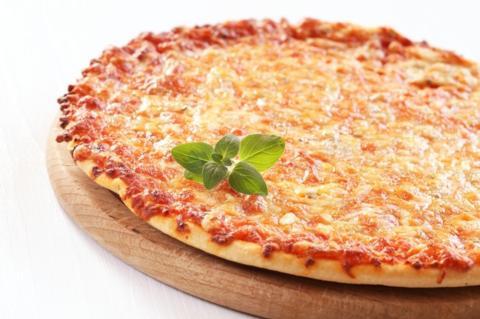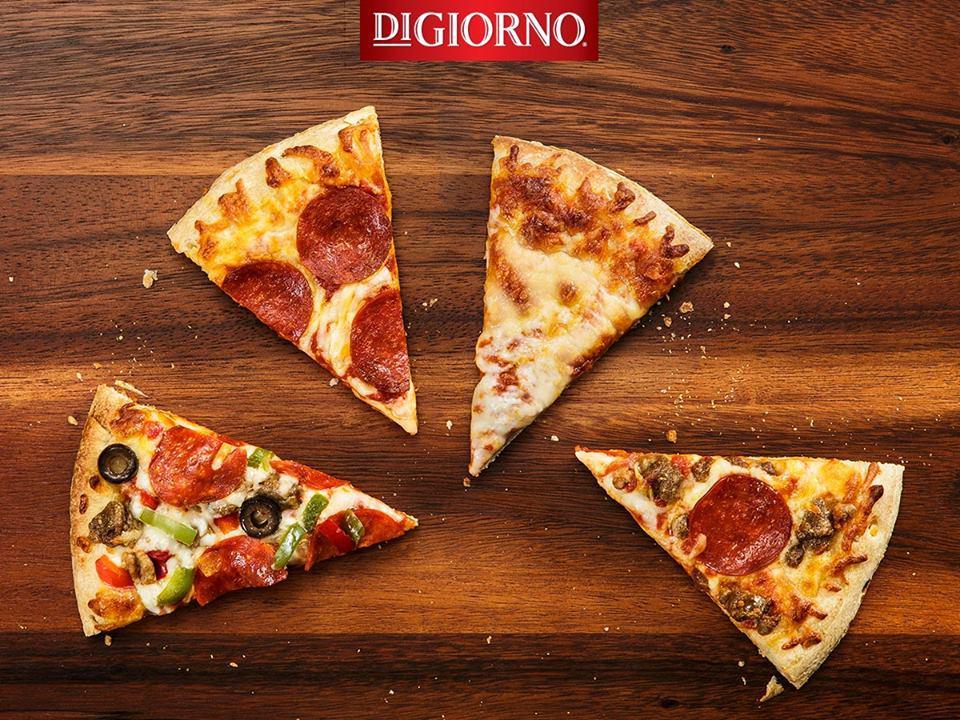The first image is the image on the left, the second image is the image on the right. Considering the images on both sides, is "All of the pizzas are cooked, whole pizzas." valid? Answer yes or no. No. The first image is the image on the left, the second image is the image on the right. Analyze the images presented: Is the assertion "There are more pizzas in the image on the right." valid? Answer yes or no. No. 